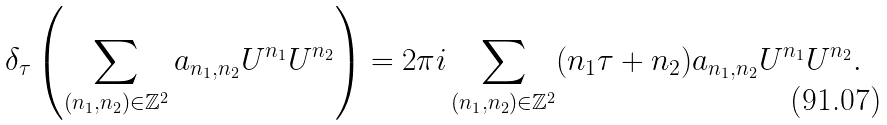Convert formula to latex. <formula><loc_0><loc_0><loc_500><loc_500>\delta _ { \tau } \left ( \sum _ { ( n _ { 1 } , n _ { 2 } ) \in \mathbb { Z } ^ { 2 } } a _ { n _ { 1 } , n _ { 2 } } U ^ { n _ { 1 } } U ^ { n _ { 2 } } \right ) = 2 \pi i \sum _ { ( n _ { 1 } , n _ { 2 } ) \in \mathbb { Z } ^ { 2 } } ( n _ { 1 } \tau + n _ { 2 } ) a _ { n _ { 1 } , n _ { 2 } } U ^ { n _ { 1 } } U ^ { n _ { 2 } } .</formula> 